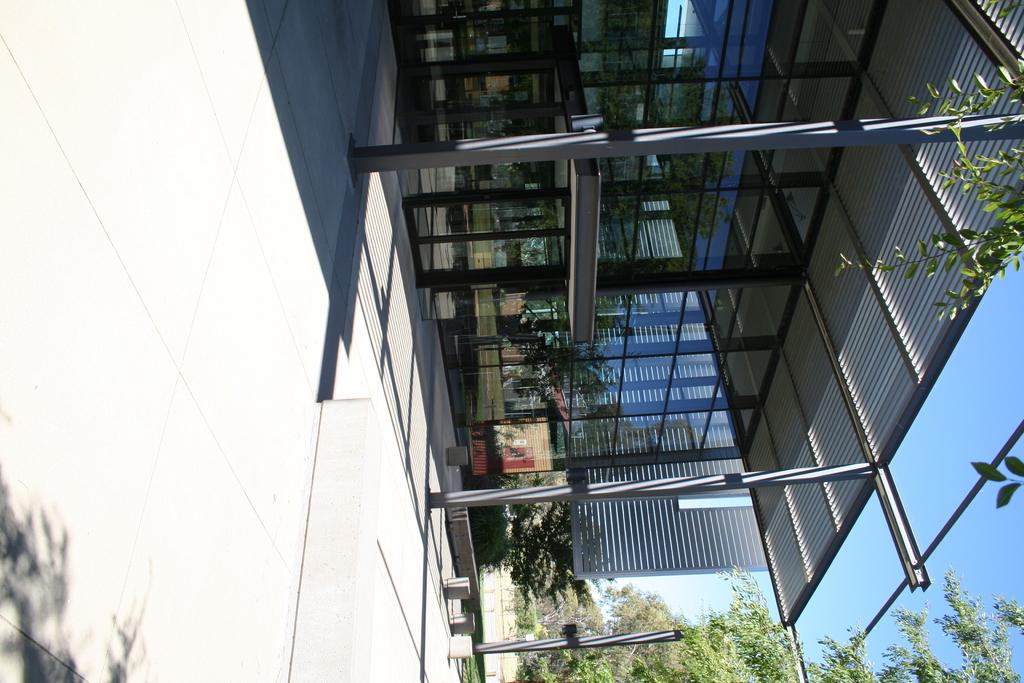What type of building is in the center of the image? There is a glass building in the center of the image. What is located above the building in the image? There is a roof visible in the image. What structures can be seen supporting the roof in the image? There are poles in the image. What can be seen in the background of the image? The sky, trees, and plant pots are visible in the background of the image. Who is the manager of the yam farm in the image? There is no yam farm or manager present in the image. 